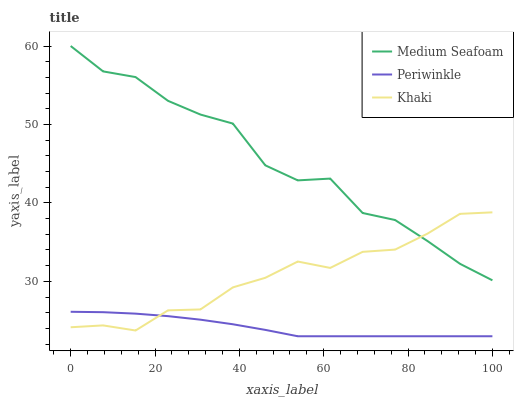Does Medium Seafoam have the minimum area under the curve?
Answer yes or no. No. Does Periwinkle have the maximum area under the curve?
Answer yes or no. No. Is Medium Seafoam the smoothest?
Answer yes or no. No. Is Periwinkle the roughest?
Answer yes or no. No. Does Medium Seafoam have the lowest value?
Answer yes or no. No. Does Periwinkle have the highest value?
Answer yes or no. No. Is Periwinkle less than Medium Seafoam?
Answer yes or no. Yes. Is Medium Seafoam greater than Periwinkle?
Answer yes or no. Yes. Does Periwinkle intersect Medium Seafoam?
Answer yes or no. No. 